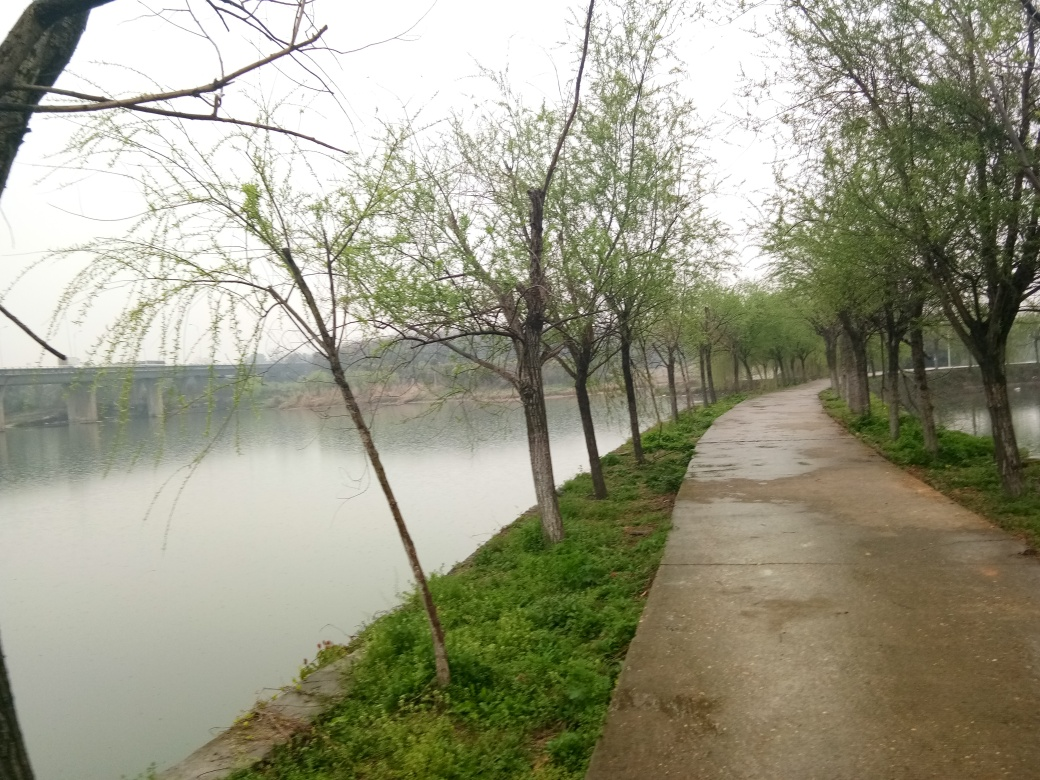What activities do you think this path is typically used for? This path appears well-suited for leisurely walks, morning jogs, and casual cycling. Its proximity to the river offers a picturesque route for relaxation and exercise, allowing visitors to enjoy the natural scenery and the calming effect of the water nearby. Does the weather in the image affect how you might prepare for those activities? Yes, the overcast sky and hints of wetness on the path suggest that the weather is cool and possibly rainy. One should dress in layers, wear water-resistant clothing, and use footwear with good traction to comfortably and safely enjoy activities along this path in such conditions. 